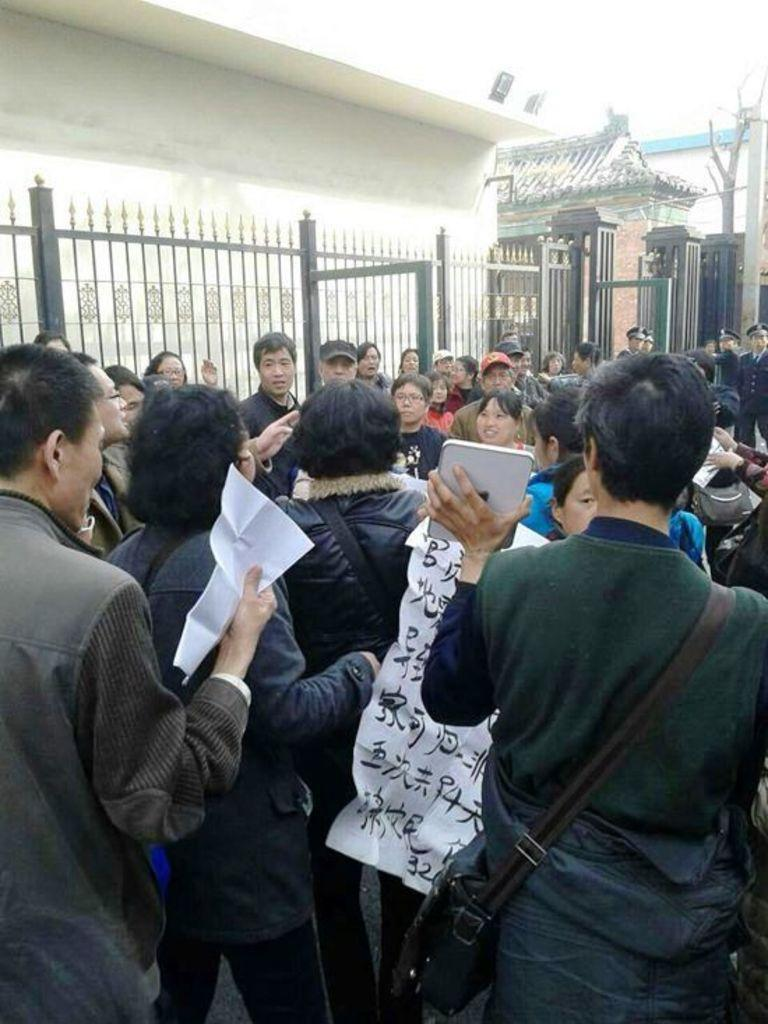What is happening in the center of the image? There are people standing in the center of the image. What can be seen in the background of the image? There are houses in the background of the image. What type of fencing is present in the image? There is a metal fencing in the image. What type of lead can be seen in the image? There is no lead present in the image. What scientific theory is being discussed by the people in the image? The image does not provide any information about a scientific theory being discussed. 